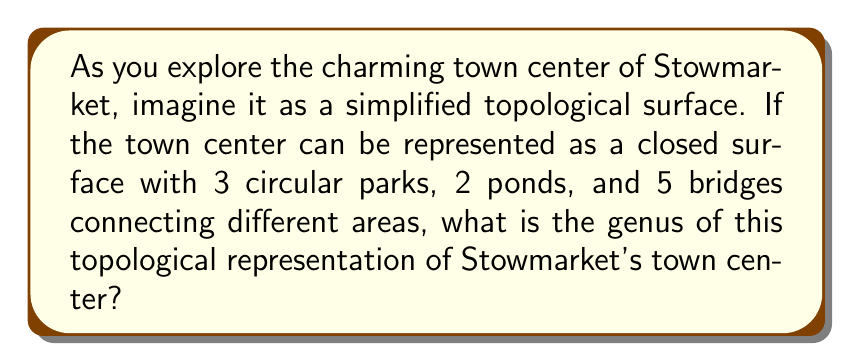Can you answer this question? To calculate the genus of the topological representation of Stowmarket's town center, we need to use the Euler characteristic formula and the relationship between Euler characteristic and genus for a closed orientable surface.

1. First, let's identify the components of our topological surface:
   - Vertices (V): Let's assume each park and pond is a vertex, so V = 5
   - Edges (E): We have 5 bridges, so E = 5
   - Faces (F): The remaining areas between parks, ponds, and bridges form the faces. Let's assume there are 2 such faces.

2. Now, we can calculate the Euler characteristic (χ) using the formula:

   $$χ = V - E + F$$

   Substituting our values:
   $$χ = 5 - 5 + 2 = 2$$

3. For a closed orientable surface, the relationship between Euler characteristic (χ) and genus (g) is given by:

   $$χ = 2 - 2g$$

4. We can now solve for g:

   $$2 = 2 - 2g$$
   $$2g = 0$$
   $$g = 0$$

5. Interpretation: A genus of 0 corresponds to a topological sphere. This means that the simplified representation of Stowmarket's town center is topologically equivalent to a sphere with additional features (parks, ponds, and bridges) on its surface.
Answer: The genus of the topological representation of Stowmarket's town center is $g = 0$. 